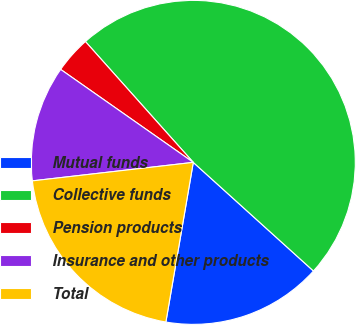Convert chart to OTSL. <chart><loc_0><loc_0><loc_500><loc_500><pie_chart><fcel>Mutual funds<fcel>Collective funds<fcel>Pension products<fcel>Insurance and other products<fcel>Total<nl><fcel>16.01%<fcel>48.29%<fcel>3.67%<fcel>11.55%<fcel>20.47%<nl></chart> 